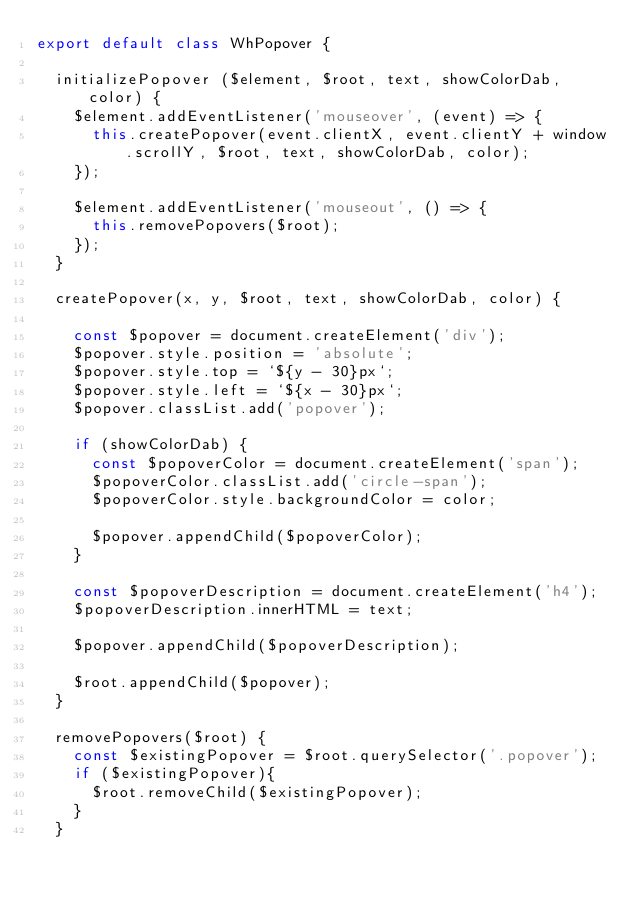Convert code to text. <code><loc_0><loc_0><loc_500><loc_500><_JavaScript_>export default class WhPopover {

  initializePopover ($element, $root, text, showColorDab, color) {
    $element.addEventListener('mouseover', (event) => {
      this.createPopover(event.clientX, event.clientY + window.scrollY, $root, text, showColorDab, color);
    });

    $element.addEventListener('mouseout', () => {
      this.removePopovers($root);
    });
  }

  createPopover(x, y, $root, text, showColorDab, color) {    

    const $popover = document.createElement('div');
    $popover.style.position = 'absolute';
    $popover.style.top = `${y - 30}px`;
    $popover.style.left = `${x - 30}px`;
    $popover.classList.add('popover');

    if (showColorDab) {
      const $popoverColor = document.createElement('span');
      $popoverColor.classList.add('circle-span');
      $popoverColor.style.backgroundColor = color;

      $popover.appendChild($popoverColor);
    }

    const $popoverDescription = document.createElement('h4');  
    $popoverDescription.innerHTML = text;

    $popover.appendChild($popoverDescription);

    $root.appendChild($popover);
  }

  removePopovers($root) {
    const $existingPopover = $root.querySelector('.popover');
    if ($existingPopover){
      $root.removeChild($existingPopover);
    }
  }</code> 